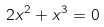Convert formula to latex. <formula><loc_0><loc_0><loc_500><loc_500>2 x ^ { 2 } + x ^ { 3 } = 0</formula> 